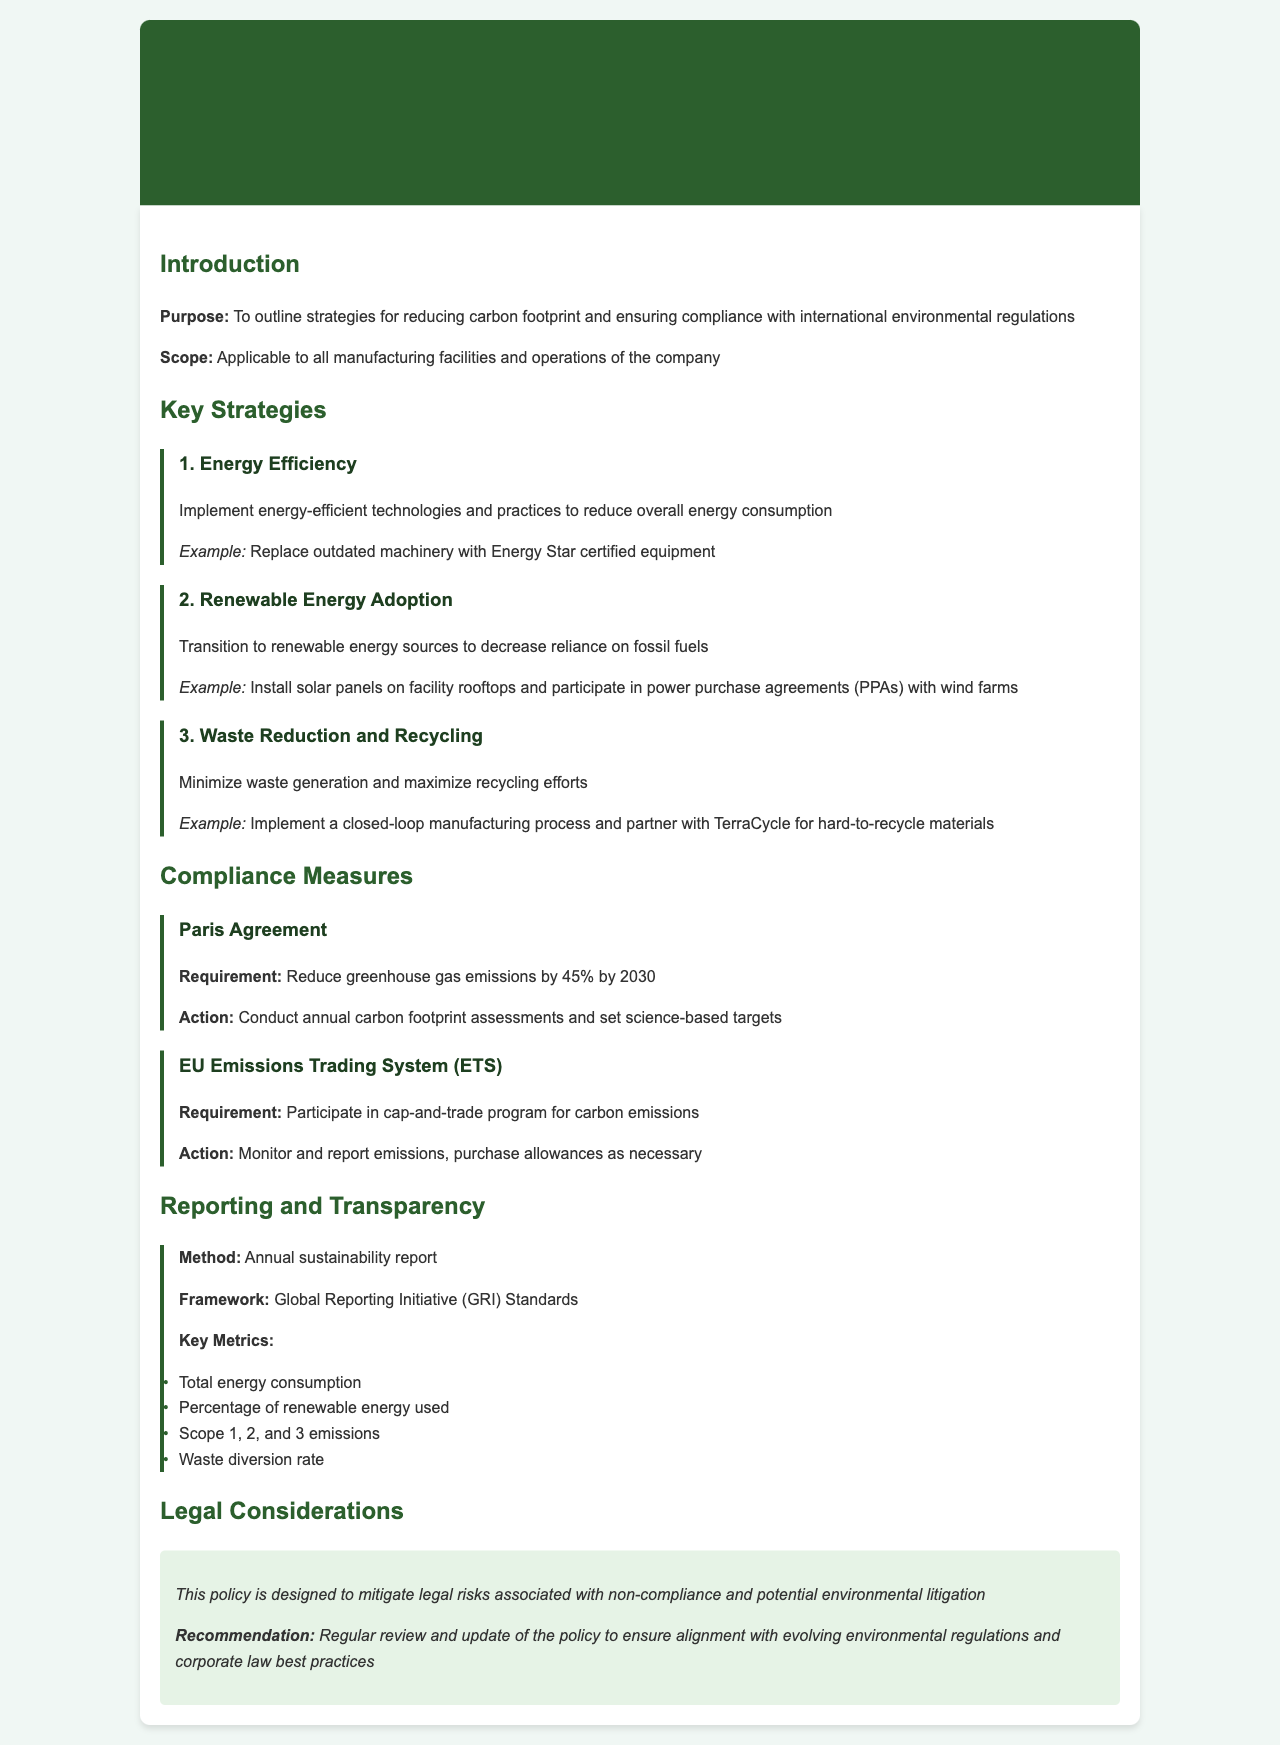What is the purpose of the policy? The purpose is to outline strategies for reducing carbon footprint and ensuring compliance with international environmental regulations.
Answer: To outline strategies for reducing carbon footprint and ensuring compliance with international environmental regulations What is the key strategy related to energy? The key strategy related to energy efficiency is to implement energy-efficient technologies and practices to reduce overall energy consumption.
Answer: Implement energy-efficient technologies and practices What percentage reduction in greenhouse gas emissions is required by the Paris Agreement by 2030? The document specifies a requirement to reduce greenhouse gas emissions by 45% by 2030.
Answer: 45% Which compliance measure involves a cap-and-trade program? The compliance measure that involves a cap-and-trade program is the EU Emissions Trading System (ETS).
Answer: EU Emissions Trading System (ETS) What framework is used for the annual sustainability report? The framework for the annual sustainability report is the Global Reporting Initiative (GRI) Standards.
Answer: Global Reporting Initiative (GRI) Standards What is the recommended action regarding the policy? The recommended action is to regularly review and update the policy to ensure alignment with evolving environmental regulations and corporate law best practices.
Answer: Regular review and update of the policy What type of report is mentioned in the reporting section? The type of report mentioned is the annual sustainability report.
Answer: Annual sustainability report What example is given for waste reduction? An example given for waste reduction is implementing a closed-loop manufacturing process and partnering with TerraCycle for hard-to-recycle materials.
Answer: Implement a closed-loop manufacturing process and partner with TerraCycle What key metric is measured related to waste? The key metric related to waste is the waste diversion rate.
Answer: Waste diversion rate 